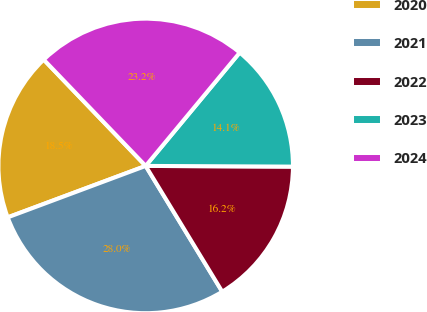<chart> <loc_0><loc_0><loc_500><loc_500><pie_chart><fcel>2020<fcel>2021<fcel>2022<fcel>2023<fcel>2024<nl><fcel>18.51%<fcel>28.02%<fcel>16.22%<fcel>14.05%<fcel>23.19%<nl></chart> 